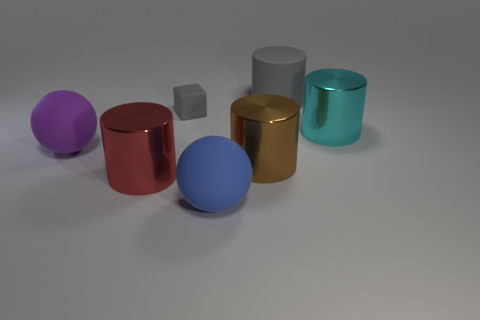Do the thing that is behind the tiny gray thing and the small rubber block on the right side of the red shiny cylinder have the same color?
Provide a succinct answer. Yes. Does the cylinder that is behind the cyan cylinder have the same size as the small gray cube?
Your answer should be compact. No. There is a ball that is behind the large matte object in front of the big brown thing; what is its material?
Your answer should be compact. Rubber. What is the large object that is on the left side of the tiny matte object and in front of the big brown metal cylinder made of?
Your answer should be very brief. Metal. How many other objects have the same shape as the large blue object?
Offer a very short reply. 1. There is a cylinder that is on the left side of the gray thing on the left side of the rubber sphere on the right side of the small gray cube; what is its size?
Give a very brief answer. Large. Are there more large objects that are in front of the tiny gray matte thing than small objects?
Give a very brief answer. Yes. Are any red shiny objects visible?
Offer a terse response. Yes. What number of gray cubes have the same size as the brown metallic cylinder?
Provide a succinct answer. 0. Is the number of large shiny cylinders behind the red cylinder greater than the number of large gray objects behind the big cyan metal cylinder?
Give a very brief answer. Yes. 